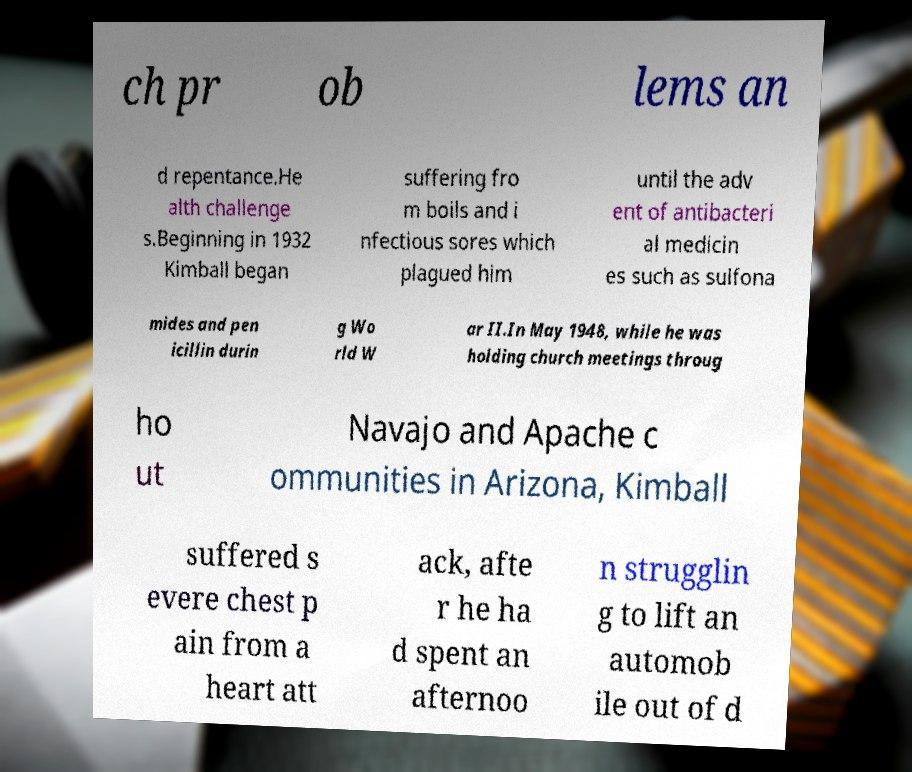Can you read and provide the text displayed in the image?This photo seems to have some interesting text. Can you extract and type it out for me? ch pr ob lems an d repentance.He alth challenge s.Beginning in 1932 Kimball began suffering fro m boils and i nfectious sores which plagued him until the adv ent of antibacteri al medicin es such as sulfona mides and pen icillin durin g Wo rld W ar II.In May 1948, while he was holding church meetings throug ho ut Navajo and Apache c ommunities in Arizona, Kimball suffered s evere chest p ain from a heart att ack, afte r he ha d spent an afternoo n strugglin g to lift an automob ile out of d 